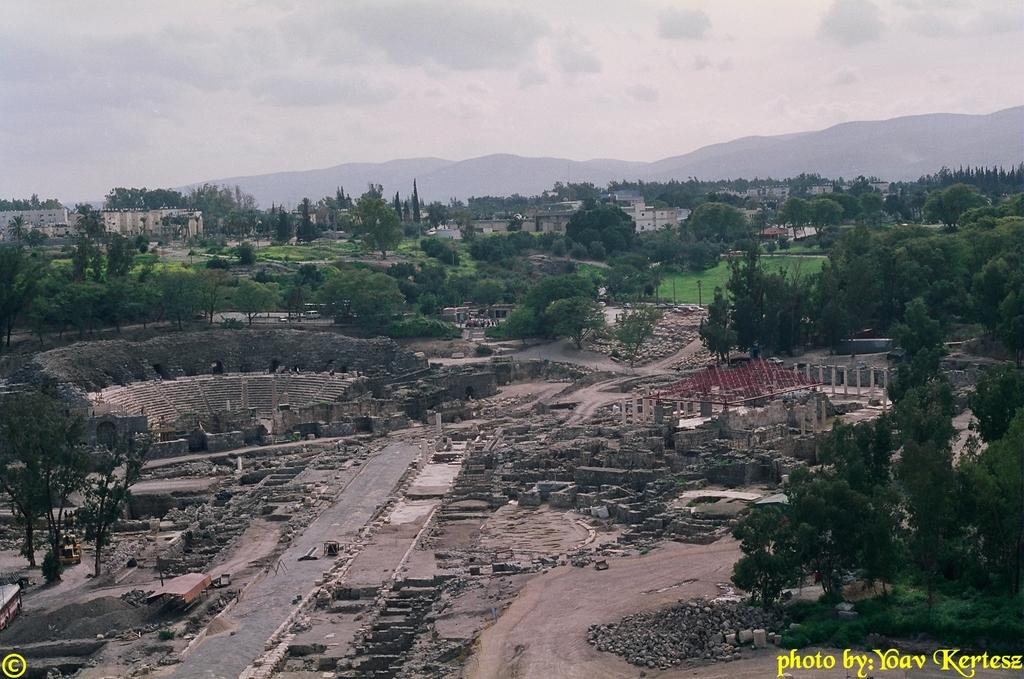What type of structures can be seen in the image? There are buildings in the image. What natural elements are present in the image? There are trees, rocks, and hills in the image. What is visible in the background of the image? The sky is visible in the background of the image. Are there any watermarks on the image? Yes, there are watermarks on the image. What type of knowledge is being shared during the vacation in the image? There is no indication of a vacation or knowledge sharing in the image; it features buildings, trees, rocks, hills, and the sky. What season is depicted in the image? The provided facts do not mention a specific season, so it cannot be determined from the image. 